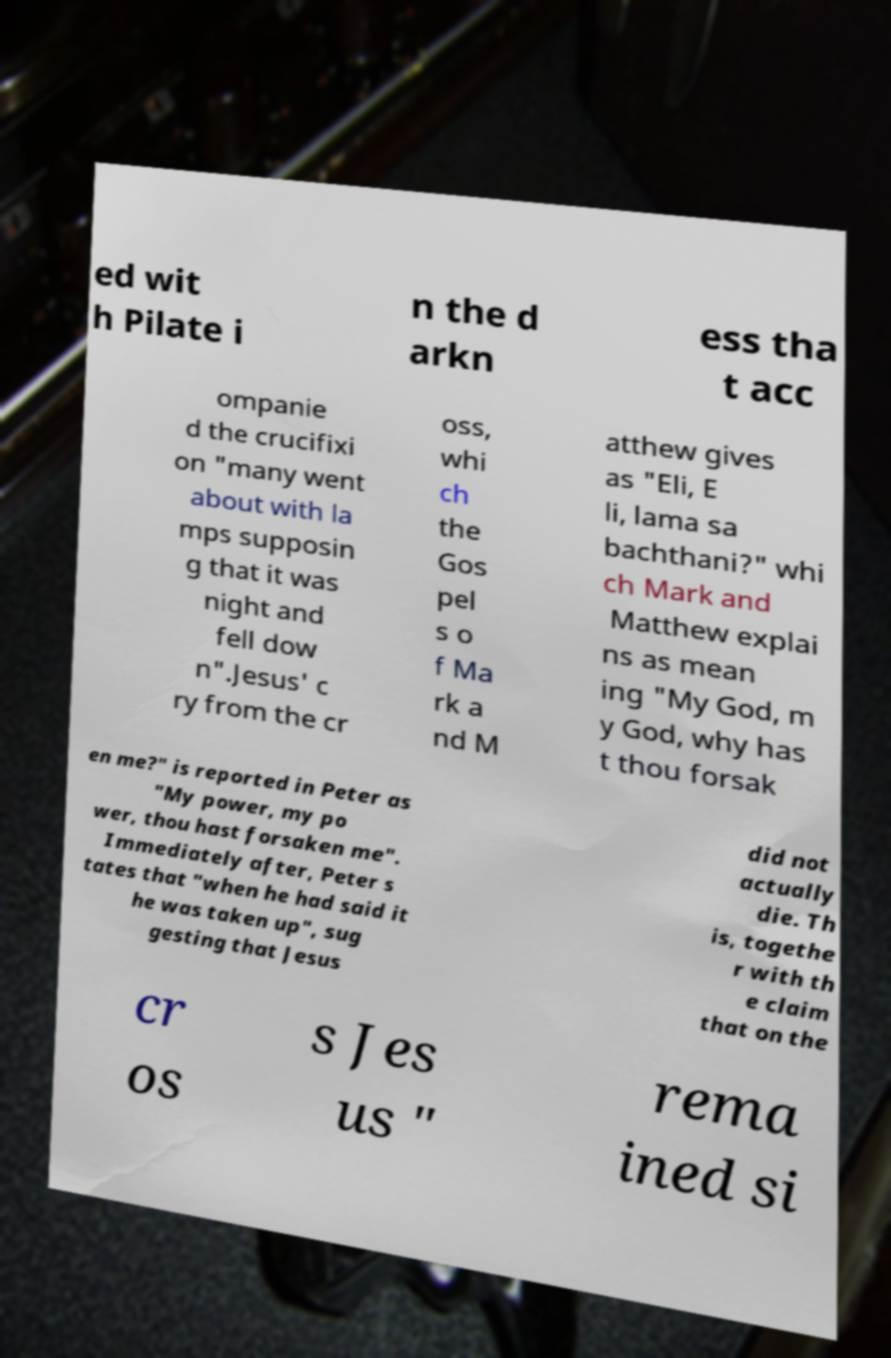Please identify and transcribe the text found in this image. ed wit h Pilate i n the d arkn ess tha t acc ompanie d the crucifixi on "many went about with la mps supposin g that it was night and fell dow n".Jesus' c ry from the cr oss, whi ch the Gos pel s o f Ma rk a nd M atthew gives as "Eli, E li, lama sa bachthani?" whi ch Mark and Matthew explai ns as mean ing "My God, m y God, why has t thou forsak en me?" is reported in Peter as "My power, my po wer, thou hast forsaken me". Immediately after, Peter s tates that "when he had said it he was taken up", sug gesting that Jesus did not actually die. Th is, togethe r with th e claim that on the cr os s Jes us " rema ined si 